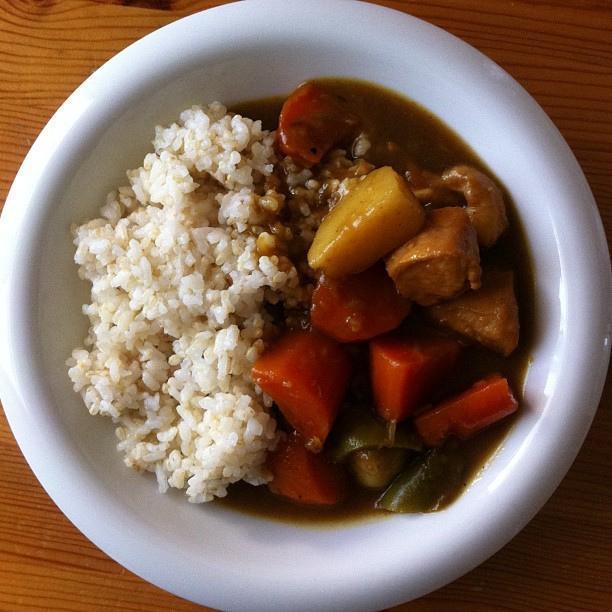How many carrots are in the photo?
Give a very brief answer. 2. 